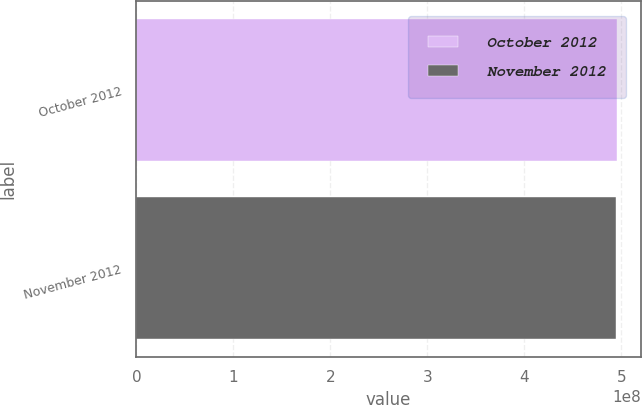Convert chart to OTSL. <chart><loc_0><loc_0><loc_500><loc_500><bar_chart><fcel>October 2012<fcel>November 2012<nl><fcel>4.9539e+08<fcel>4.944e+08<nl></chart> 